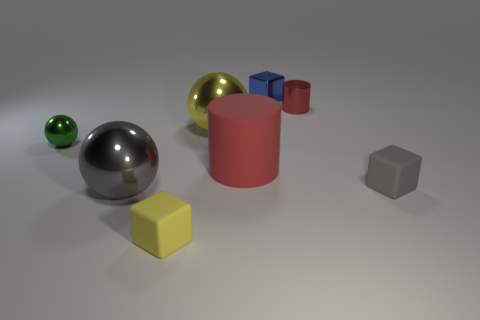Add 1 small gray matte things. How many objects exist? 9 Subtract all cubes. How many objects are left? 5 Subtract all blocks. Subtract all gray rubber cubes. How many objects are left? 4 Add 4 small gray rubber blocks. How many small gray rubber blocks are left? 5 Add 4 tiny blue metallic cubes. How many tiny blue metallic cubes exist? 5 Subtract 0 blue spheres. How many objects are left? 8 